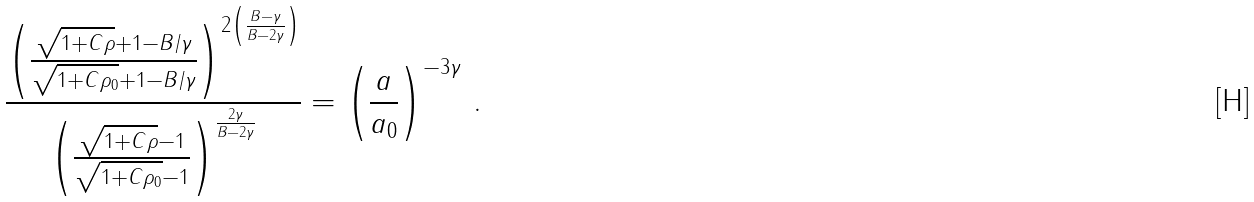Convert formula to latex. <formula><loc_0><loc_0><loc_500><loc_500>\frac { \left ( \frac { \sqrt { 1 + C \rho } + 1 - B / \gamma } { \sqrt { 1 + C \rho _ { 0 } } + 1 - B / \gamma } \right ) ^ { 2 \left ( \frac { B - \gamma } { B - 2 \gamma } \right ) } } { \left ( \frac { \sqrt { 1 + C \rho } - 1 } { \sqrt { 1 + C \rho _ { 0 } } - 1 } \right ) ^ { \frac { 2 \gamma } { B - 2 \gamma } } } = \left ( \frac { a } { a _ { 0 } } \right ) ^ { - 3 \gamma } \, .</formula> 